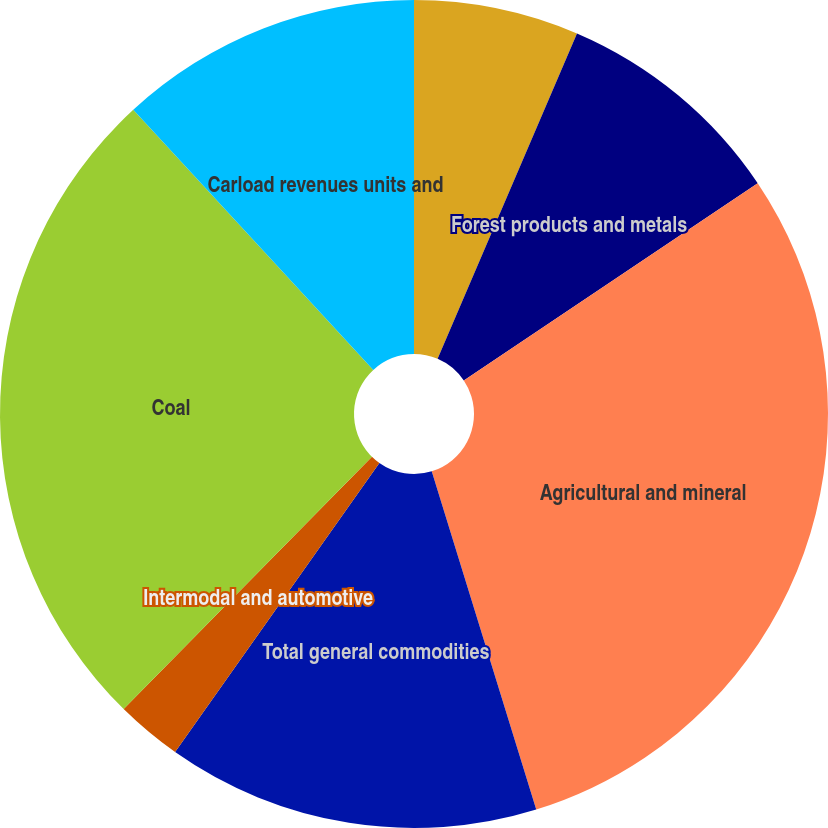<chart> <loc_0><loc_0><loc_500><loc_500><pie_chart><fcel>Chemical and petroleum<fcel>Forest products and metals<fcel>Agricultural and mineral<fcel>Total general commodities<fcel>Intermodal and automotive<fcel>Coal<fcel>Carload revenues units and<nl><fcel>6.44%<fcel>9.15%<fcel>29.64%<fcel>14.56%<fcel>2.58%<fcel>25.77%<fcel>11.86%<nl></chart> 